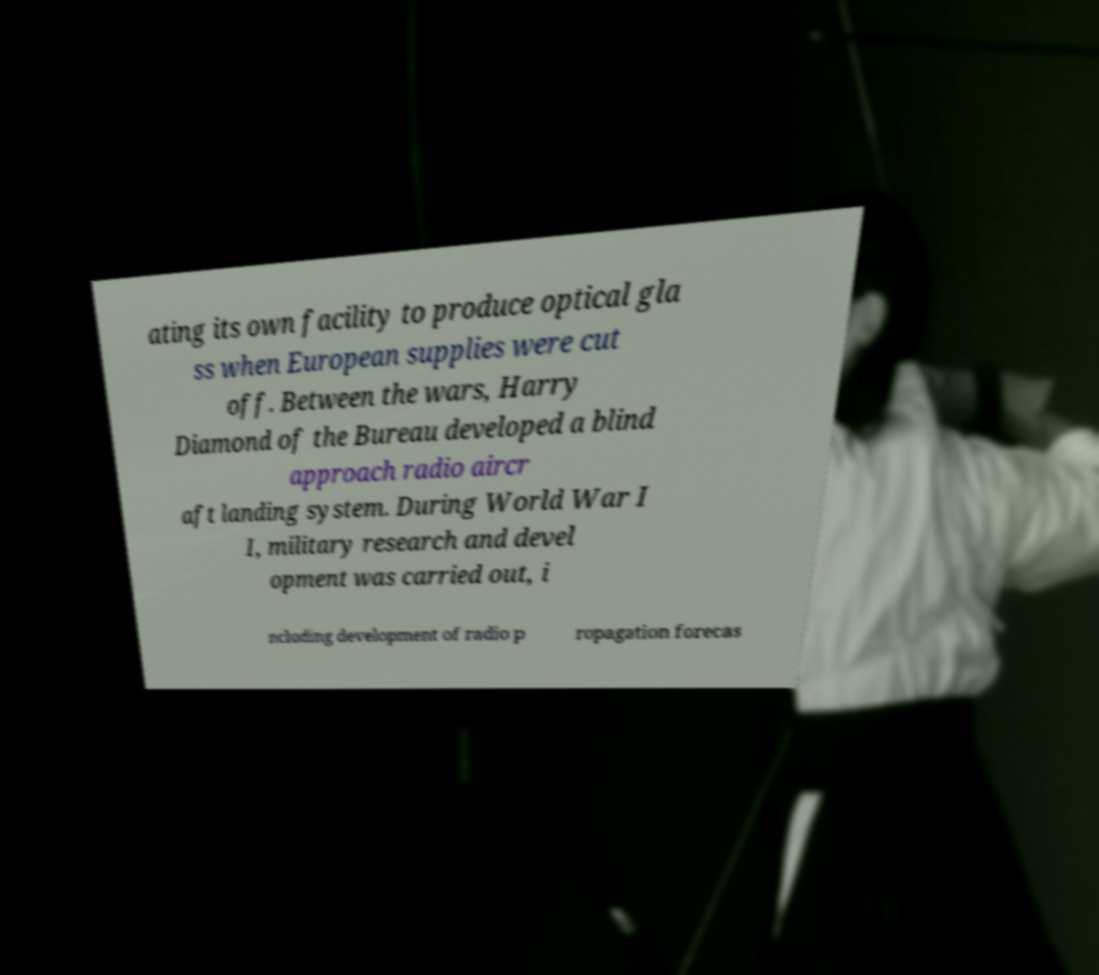Please identify and transcribe the text found in this image. ating its own facility to produce optical gla ss when European supplies were cut off. Between the wars, Harry Diamond of the Bureau developed a blind approach radio aircr aft landing system. During World War I I, military research and devel opment was carried out, i ncluding development of radio p ropagation forecas 